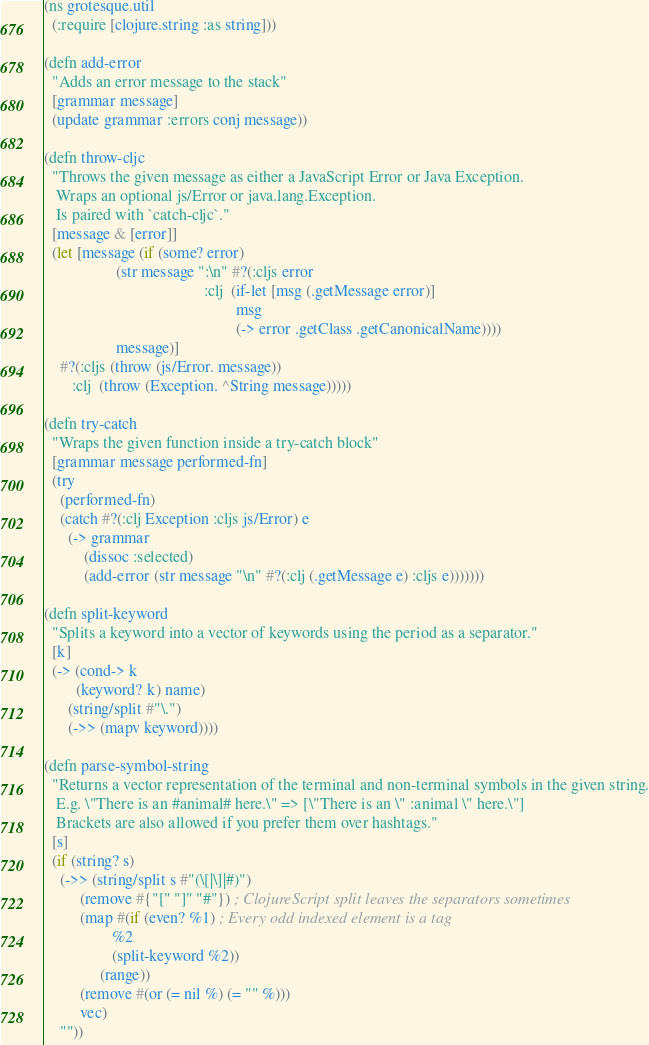Convert code to text. <code><loc_0><loc_0><loc_500><loc_500><_Clojure_>(ns grotesque.util
  (:require [clojure.string :as string]))

(defn add-error
  "Adds an error message to the stack"
  [grammar message]
  (update grammar :errors conj message))

(defn throw-cljc
  "Throws the given message as either a JavaScript Error or Java Exception.
   Wraps an optional js/Error or java.lang.Exception.
   Is paired with `catch-cljc`."
  [message & [error]]
  (let [message (if (some? error)
                  (str message ":\n" #?(:cljs error
                                        :clj  (if-let [msg (.getMessage error)]
                                                msg
                                                (-> error .getClass .getCanonicalName))))
                  message)]
    #?(:cljs (throw (js/Error. message))
       :clj  (throw (Exception. ^String message)))))

(defn try-catch
  "Wraps the given function inside a try-catch block"
  [grammar message performed-fn]
  (try
    (performed-fn)
    (catch #?(:clj Exception :cljs js/Error) e
      (-> grammar
          (dissoc :selected)
          (add-error (str message "\n" #?(:clj (.getMessage e) :cljs e)))))))

(defn split-keyword
  "Splits a keyword into a vector of keywords using the period as a separator."
  [k]
  (-> (cond-> k
        (keyword? k) name)
      (string/split #"\.")
      (->> (mapv keyword))))

(defn parse-symbol-string
  "Returns a vector representation of the terminal and non-terminal symbols in the given string.
   E.g. \"There is an #animal# here.\" => [\"There is an \" :animal \" here.\"]
   Brackets are also allowed if you prefer them over hashtags."
  [s]
  (if (string? s)
    (->> (string/split s #"(\[|\]|#)")
         (remove #{"[" "]" "#"}) ; ClojureScript split leaves the separators sometimes
         (map #(if (even? %1) ; Every odd indexed element is a tag
                 %2
                 (split-keyword %2))
              (range))
         (remove #(or (= nil %) (= "" %)))
         vec)
    ""))</code> 